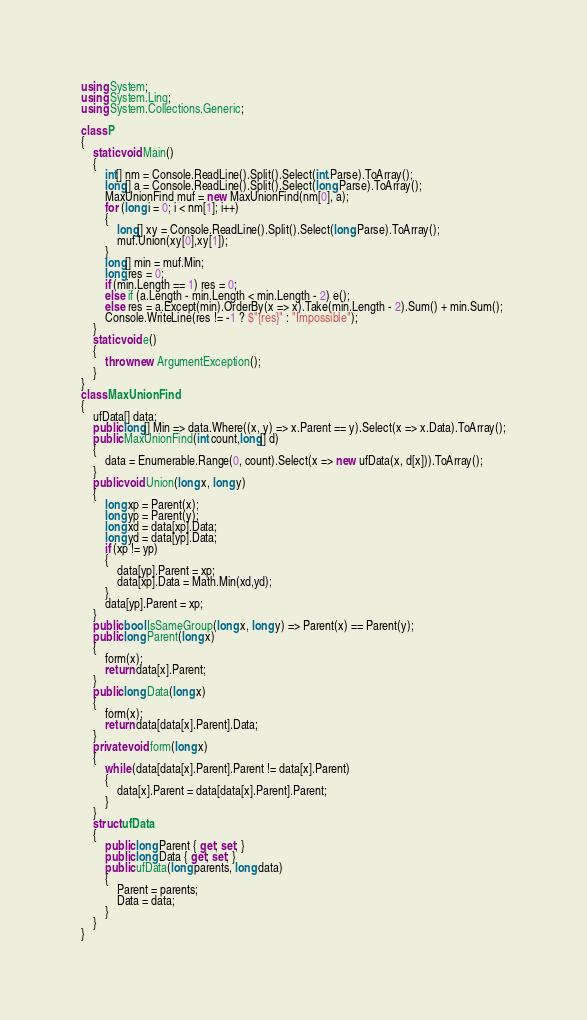Convert code to text. <code><loc_0><loc_0><loc_500><loc_500><_C#_>using System;
using System.Linq;
using System.Collections.Generic;

class P
{
    static void Main()
    {
        int[] nm = Console.ReadLine().Split().Select(int.Parse).ToArray();
        long[] a = Console.ReadLine().Split().Select(long.Parse).ToArray();
        MaxUnionFind muf = new MaxUnionFind(nm[0], a);
        for (long i = 0; i < nm[1]; i++)
        {
            long[] xy = Console.ReadLine().Split().Select(long.Parse).ToArray();
            muf.Union(xy[0],xy[1]);
        }
        long[] min = muf.Min;
        long res = 0;
        if (min.Length == 1) res = 0;
        else if (a.Length - min.Length < min.Length - 2) e();
        else res = a.Except(min).OrderBy(x => x).Take(min.Length - 2).Sum() + min.Sum();
        Console.WriteLine(res != -1 ? $"{res}" : "Impossible");
    }
    static void e()
    {
        throw new ArgumentException();
    }
}
class MaxUnionFind
{
    ufData[] data;
    public long[] Min => data.Where((x, y) => x.Parent == y).Select(x => x.Data).ToArray();
    public MaxUnionFind(int count,long[] d)
    {
        data = Enumerable.Range(0, count).Select(x => new ufData(x, d[x])).ToArray();
    }
    public void Union(long x, long y)
    {
        long xp = Parent(x);
        long yp = Parent(y);
        long xd = data[xp].Data;
        long yd = data[yp].Data;
        if (xp != yp)
        {
            data[yp].Parent = xp;
            data[xp].Data = Math.Min(xd,yd);
        }
        data[yp].Parent = xp;
    }
    public bool IsSameGroup(long x, long y) => Parent(x) == Parent(y);
    public long Parent(long x)
    {
        form(x);
        return data[x].Parent;
    }
    public long Data(long x)
    {
        form(x);
        return data[data[x].Parent].Data;
    }
    private void form(long x)
    {
        while (data[data[x].Parent].Parent != data[x].Parent)
        {
            data[x].Parent = data[data[x].Parent].Parent;
        }
    }
    struct ufData
    {
        public long Parent { get; set; }
        public long Data { get; set; }
        public ufData(long parents, long data)
        {
            Parent = parents;
            Data = data;
        }
    }
}</code> 